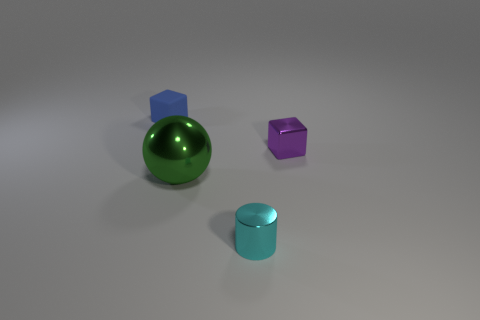Add 2 large green objects. How many objects exist? 6 Subtract all cylinders. How many objects are left? 3 Add 3 tiny purple cubes. How many tiny purple cubes are left? 4 Add 1 yellow rubber blocks. How many yellow rubber blocks exist? 1 Subtract 0 red balls. How many objects are left? 4 Subtract all blue blocks. Subtract all small purple blocks. How many objects are left? 2 